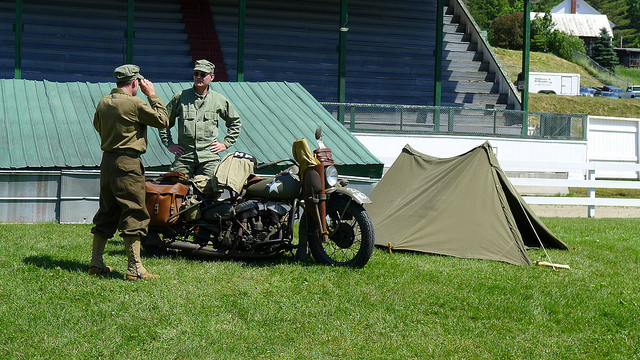Which one is the superior officer?
A. facing camera
B. back turned
C. can't tell
D. in trailer There is no clear indication of rank visible on the uniforms of the individuals in the image, so it isn't possible to accurately determine the superior officer just based on their orientation towards the camera. The individuals' body language suggests a casual interaction which does not reflect a distinct hierarchy. Hence, a definitive answer cannot be given based solely on this image. 